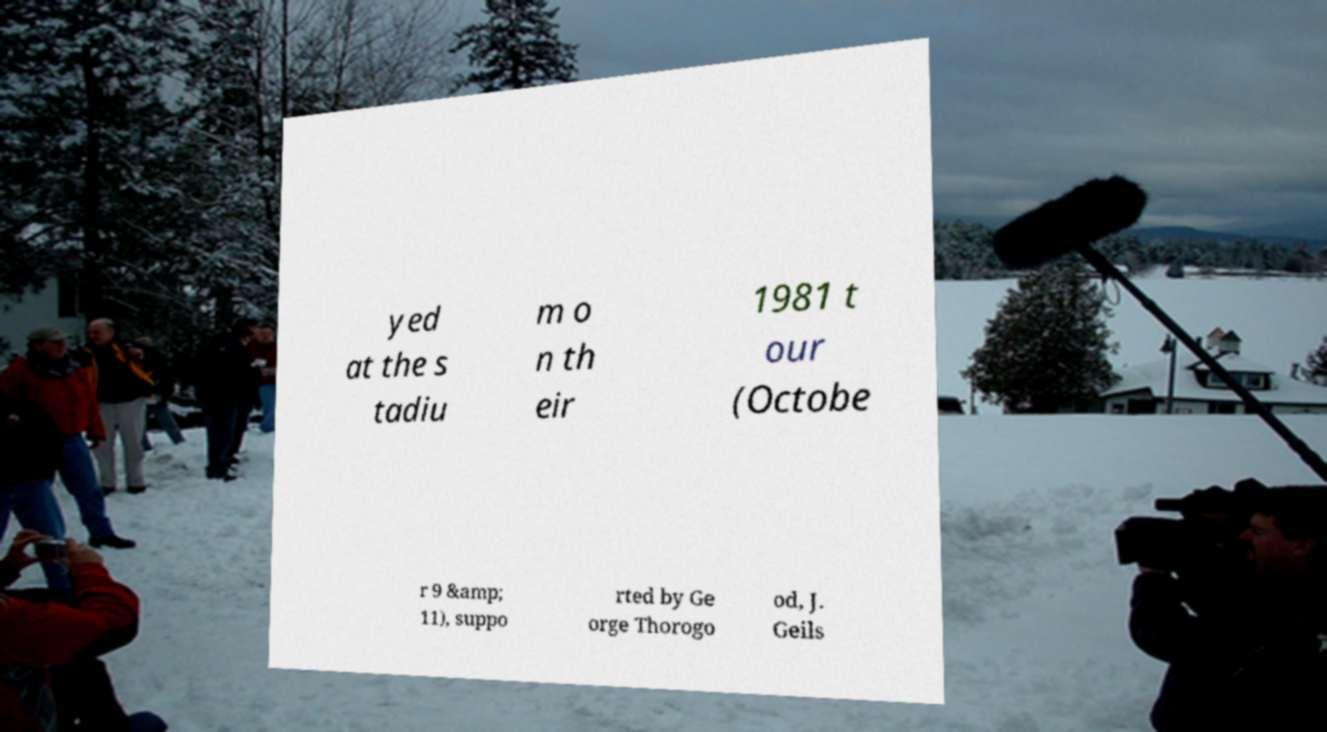Please identify and transcribe the text found in this image. yed at the s tadiu m o n th eir 1981 t our (Octobe r 9 &amp; 11), suppo rted by Ge orge Thorogo od, J. Geils 